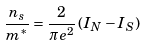Convert formula to latex. <formula><loc_0><loc_0><loc_500><loc_500>\frac { n _ { s } } { m ^ { \ast } } = \frac { 2 } { \pi e ^ { 2 } } \, ( I _ { N } - I _ { S } )</formula> 